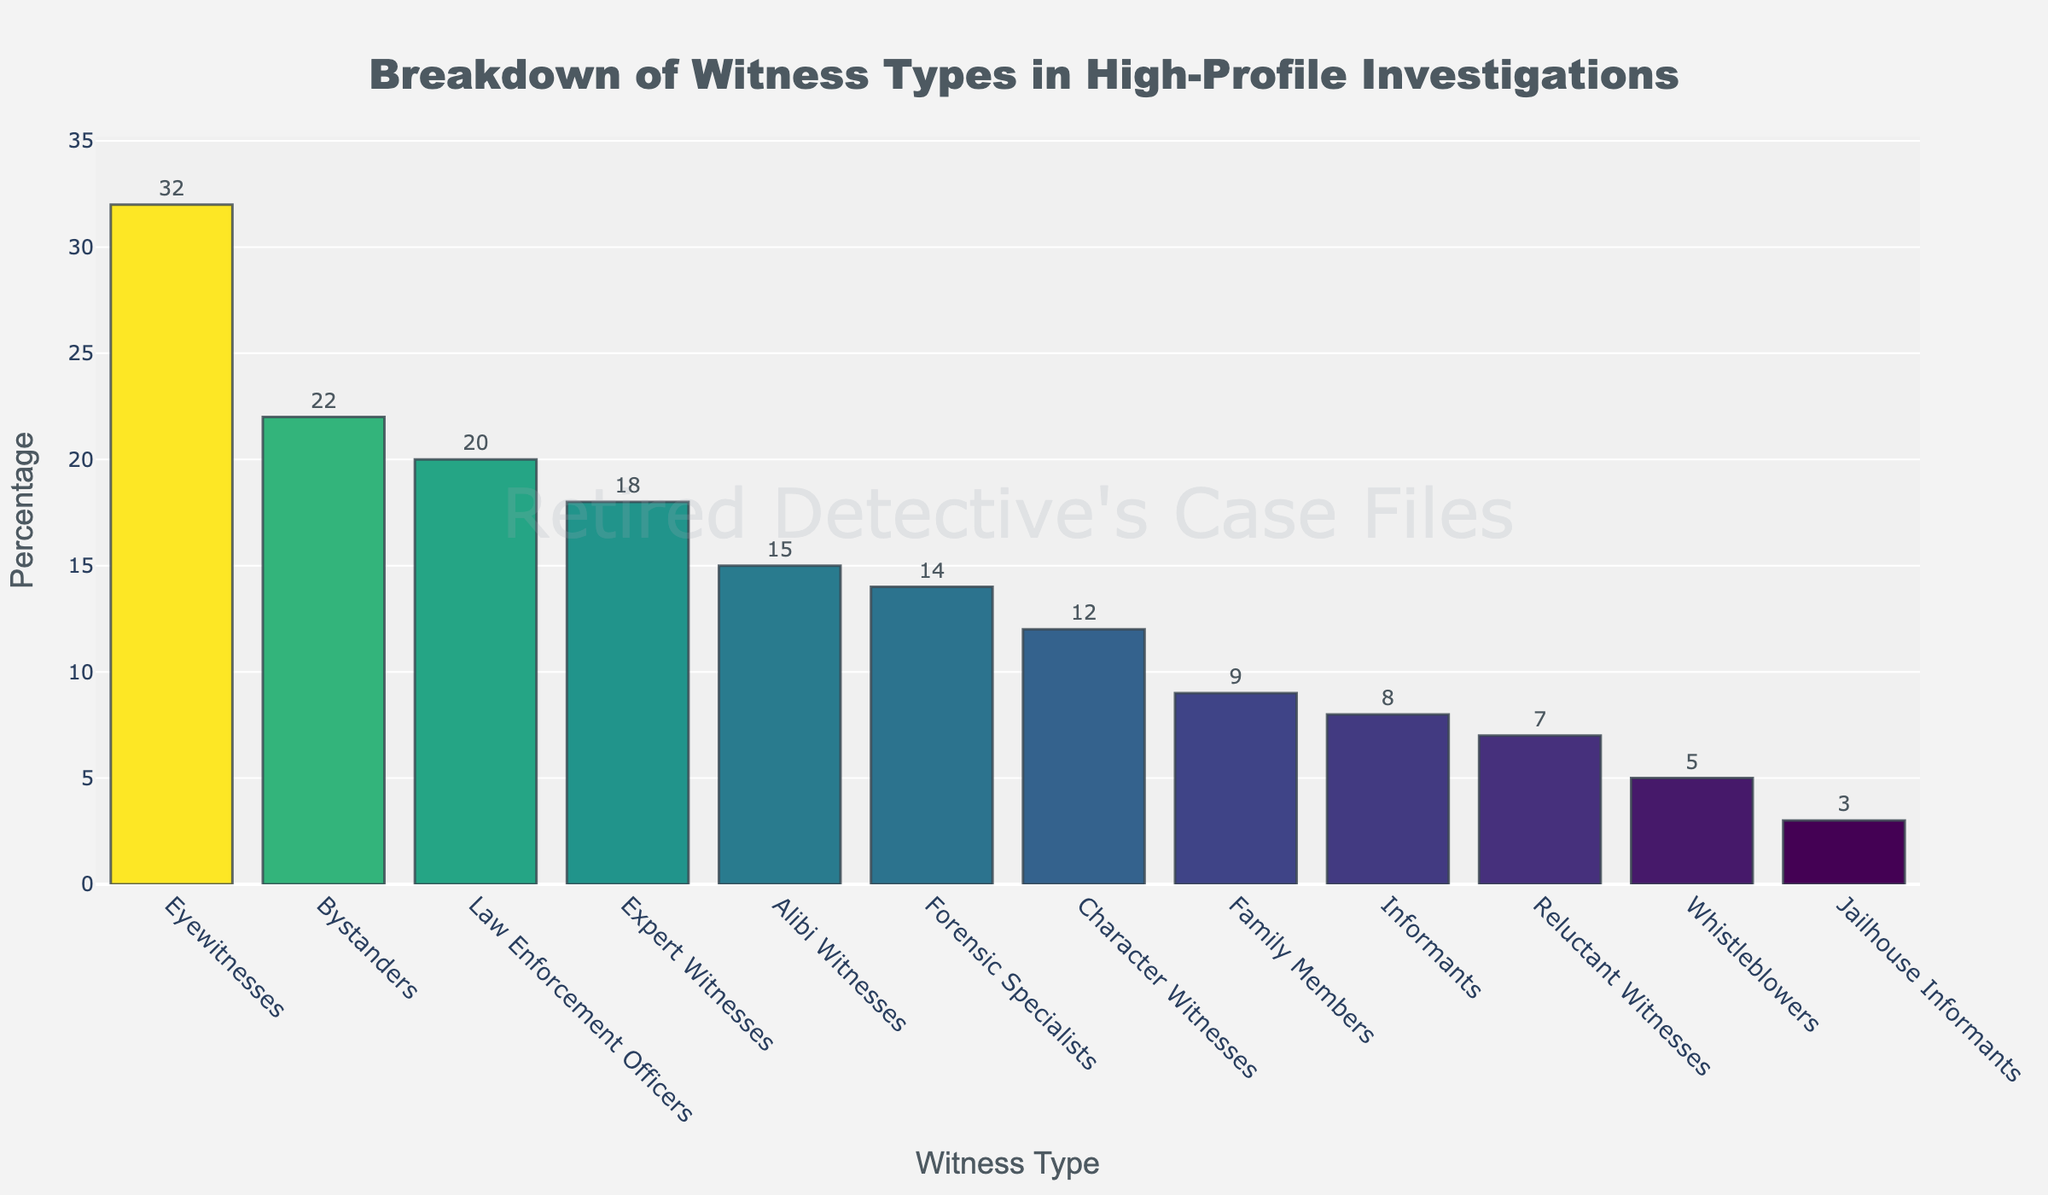What's the percentage of eyewitnesses in high-profile investigations? To find the percentage of eyewitnesses, locate the bar labeled "Eyewitnesses" on the figure and read the value next to it.
Answer: 32% Which witness type has the highest percentage in high-profile investigations? Look for the tallest bar in the figure, as it represents the witness type with the highest percentage.
Answer: Eyewitnesses What is the combined percentage of expert and alibi witnesses? Find the values for expert and alibi witnesses (18% and 15%, respectively), and sum them up: 18 + 15.
Answer: 33% Which category has a higher percentage, bystanders or law enforcement officers? Compare the heights of the bars for "Bystanders" and "Law Enforcement Officers." Bystanders have 22% and Law Enforcement Officers have 20%.
Answer: Bystanders How many types of witnesses have a percentage less than 10%? Identify all the bars with values less than 10%. There are five: Informants (8%), Family Members (9%), Reluctant Witnesses (7%), Whistleblowers (5%), and Jailhouse Informants (3%).
Answer: 5 What's the difference in percentage between character witnesses and forensic specialists? Find the values for character witnesses (12%) and forensic specialists (14%), and subtract the smaller from the larger: 14 - 12.
Answer: 2% Which witness type has the lowest percentage, and what is it? Look for the shortest bar in the figure to identify the witness type and its percentage.
Answer: Jailhouse Informants (3%) Are there more expert witnesses or character witnesses? Compare the heights of the bars for "Expert Witnesses" and "Character Witnesses." Expert Witnesses have 18% and Character Witnesses have 12%.
Answer: Expert Witnesses What is the sum of the percentages of law enforcement officers, forensic specialists, and informants? Find the respective percentages (20%, 14%, and 8%) and sum them up: 20 + 14 + 8.
Answer: 42% Which witness types have a percentage equal to or greater than 15%? Identify the bars with values equal to or greater than 15%. They are Eyewitnesses (32%), Bystanders (22%), Law Enforcement Officers (20%), and Alibi Witnesses (15%).
Answer: Eyewitnesses, Bystanders, Law Enforcement Officers, Alibi Witnesses 